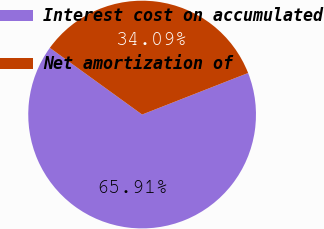<chart> <loc_0><loc_0><loc_500><loc_500><pie_chart><fcel>Interest cost on accumulated<fcel>Net amortization of<nl><fcel>65.91%<fcel>34.09%<nl></chart> 